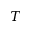<formula> <loc_0><loc_0><loc_500><loc_500>T</formula> 